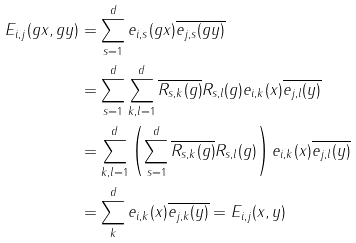Convert formula to latex. <formula><loc_0><loc_0><loc_500><loc_500>E _ { i , j } ( g x , g y ) & = \sum _ { s = 1 } ^ { d } e _ { i , s } ( g x ) \overline { e _ { j , s } ( g y ) } \\ & = \sum _ { s = 1 } ^ { d } \sum _ { k , l = 1 } ^ { d } \overline { R _ { s , k } ( g ) } R _ { s , l } ( g ) e _ { i , k } ( x ) \overline { e _ { j , l } ( y ) } \\ & = \sum _ { k , l = 1 } ^ { d } \left ( \sum _ { s = 1 } ^ { d } \overline { R _ { s , k } ( g ) } R _ { s , l } ( g ) \right ) e _ { i , k } ( x ) \overline { e _ { j , l } ( y ) } \\ & = \sum _ { k } ^ { d } e _ { i , k } ( x ) \overline { e _ { j , k } ( y ) } = E _ { i , j } ( x , y ) \\</formula> 